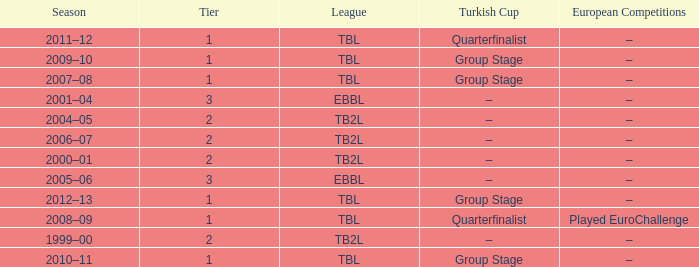Season of 2012–13 is what league? TBL. 